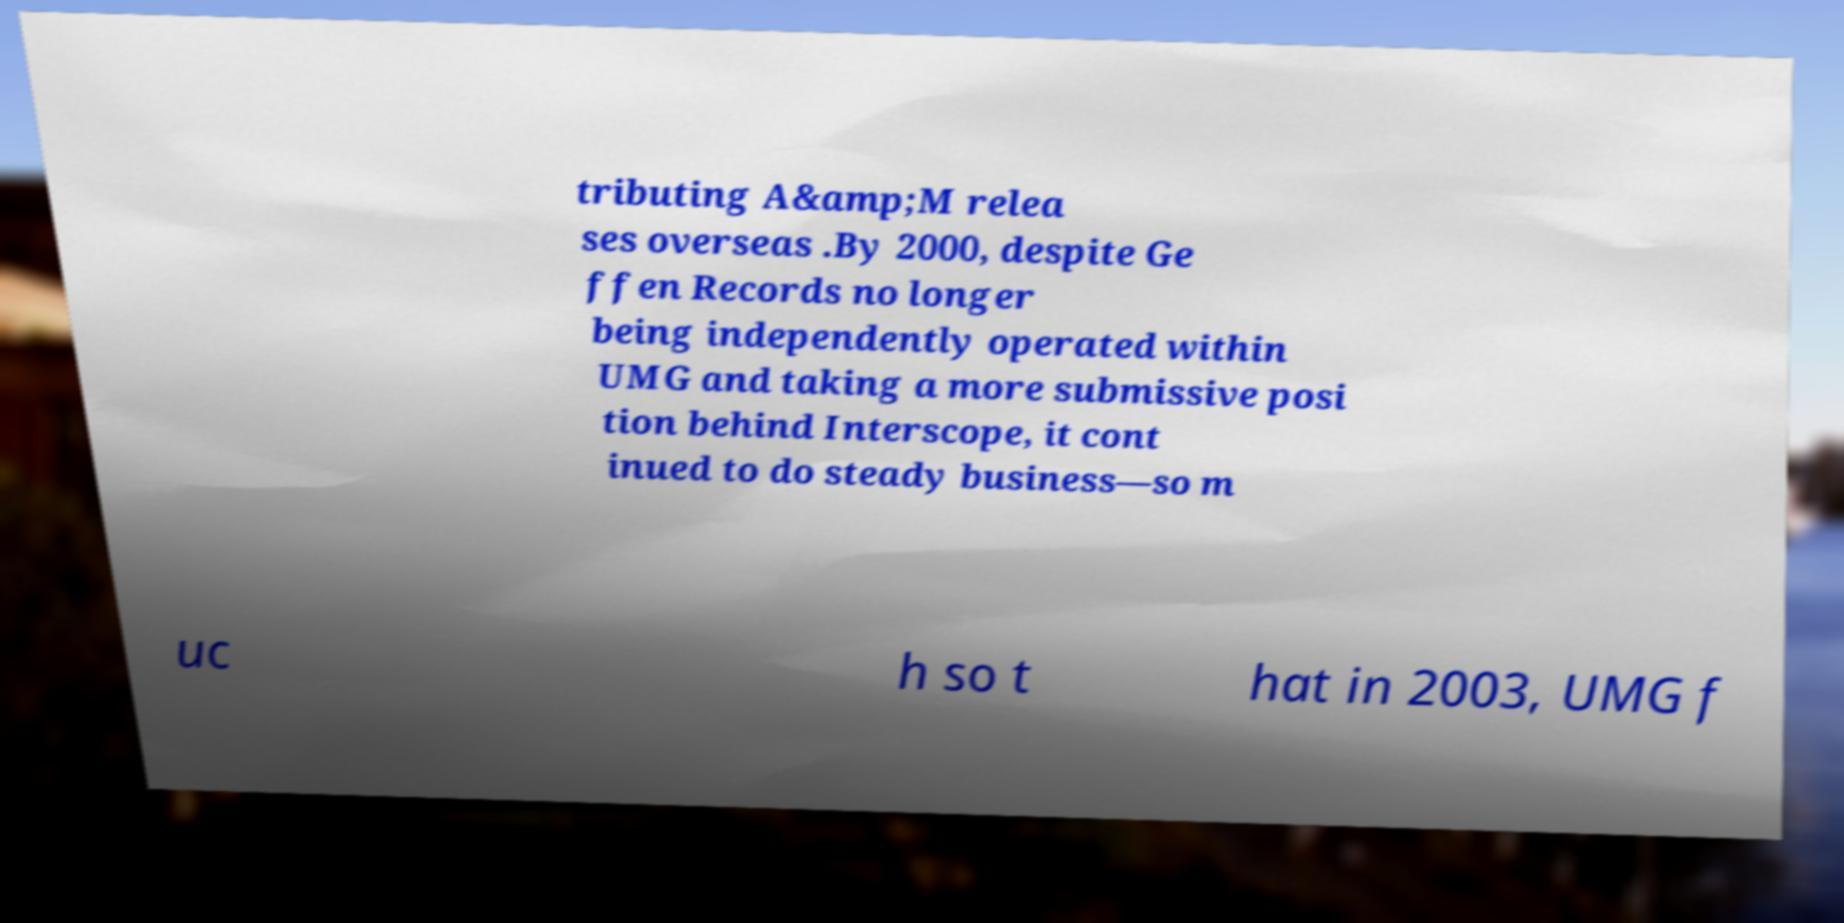Can you read and provide the text displayed in the image?This photo seems to have some interesting text. Can you extract and type it out for me? tributing A&amp;M relea ses overseas .By 2000, despite Ge ffen Records no longer being independently operated within UMG and taking a more submissive posi tion behind Interscope, it cont inued to do steady business—so m uc h so t hat in 2003, UMG f 